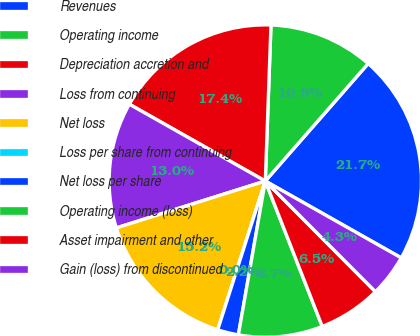<chart> <loc_0><loc_0><loc_500><loc_500><pie_chart><fcel>Revenues<fcel>Operating income<fcel>Depreciation accretion and<fcel>Loss from continuing<fcel>Net loss<fcel>Loss per share from continuing<fcel>Net loss per share<fcel>Operating income (loss)<fcel>Asset impairment and other<fcel>Gain (loss) from discontinued<nl><fcel>21.74%<fcel>10.87%<fcel>17.39%<fcel>13.04%<fcel>15.22%<fcel>0.0%<fcel>2.17%<fcel>8.7%<fcel>6.52%<fcel>4.35%<nl></chart> 